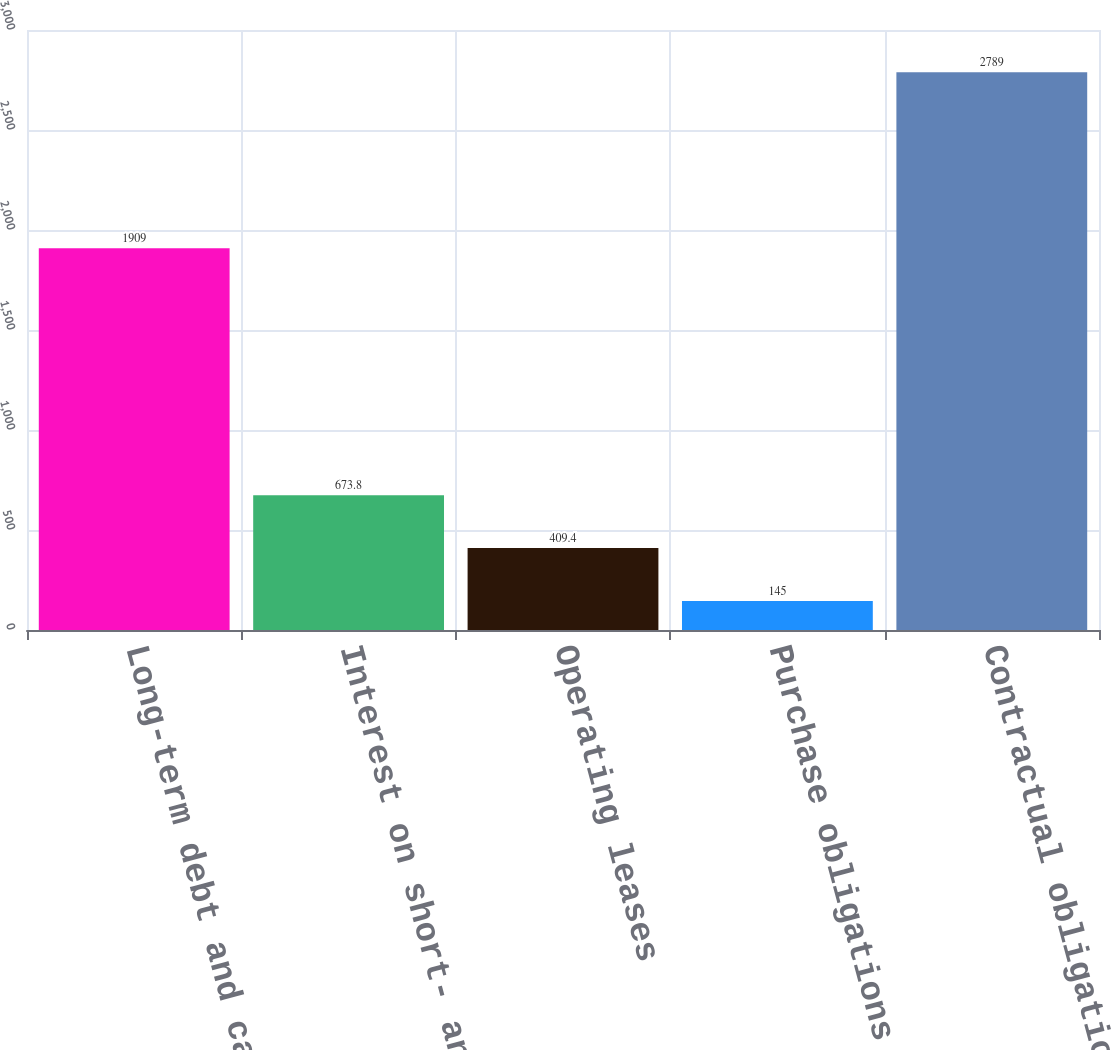<chart> <loc_0><loc_0><loc_500><loc_500><bar_chart><fcel>Long-term debt and capital<fcel>Interest on short- and<fcel>Operating leases<fcel>Purchase obligations 3<fcel>Contractual obligations 5<nl><fcel>1909<fcel>673.8<fcel>409.4<fcel>145<fcel>2789<nl></chart> 